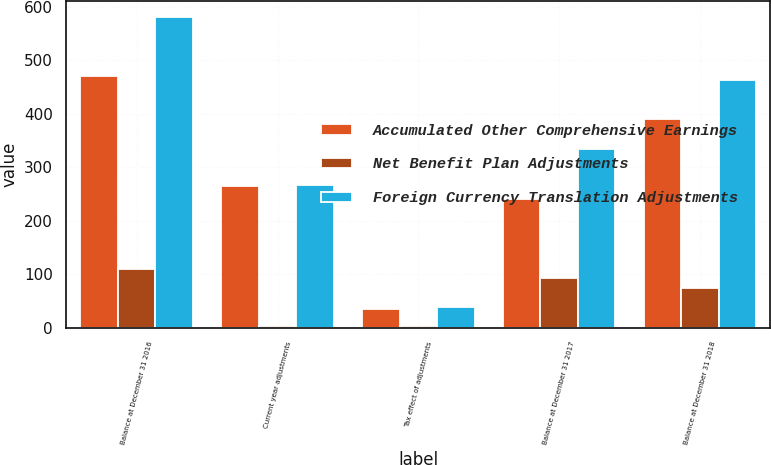Convert chart to OTSL. <chart><loc_0><loc_0><loc_500><loc_500><stacked_bar_chart><ecel><fcel>Balance at December 31 2016<fcel>Current year adjustments<fcel>Tax effect of adjustments<fcel>Balance at December 31 2017<fcel>Balance at December 31 2018<nl><fcel>Accumulated Other Comprehensive Earnings<fcel>471.5<fcel>265.1<fcel>34.3<fcel>240.7<fcel>389.8<nl><fcel>Net Benefit Plan Adjustments<fcel>110.4<fcel>2.4<fcel>3.5<fcel>93<fcel>73.3<nl><fcel>Foreign Currency Translation Adjustments<fcel>581.9<fcel>267.5<fcel>37.8<fcel>333.7<fcel>463.1<nl></chart> 